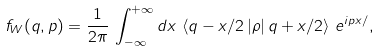Convert formula to latex. <formula><loc_0><loc_0><loc_500><loc_500>f _ { W } ( q , p ) = \frac { 1 } { 2 \pi } \, \int _ { - \infty } ^ { + \infty } d x \, \left \langle q - x / 2 \left | \rho \right | q + x / 2 \right \rangle \, e ^ { i p x / } ,</formula> 